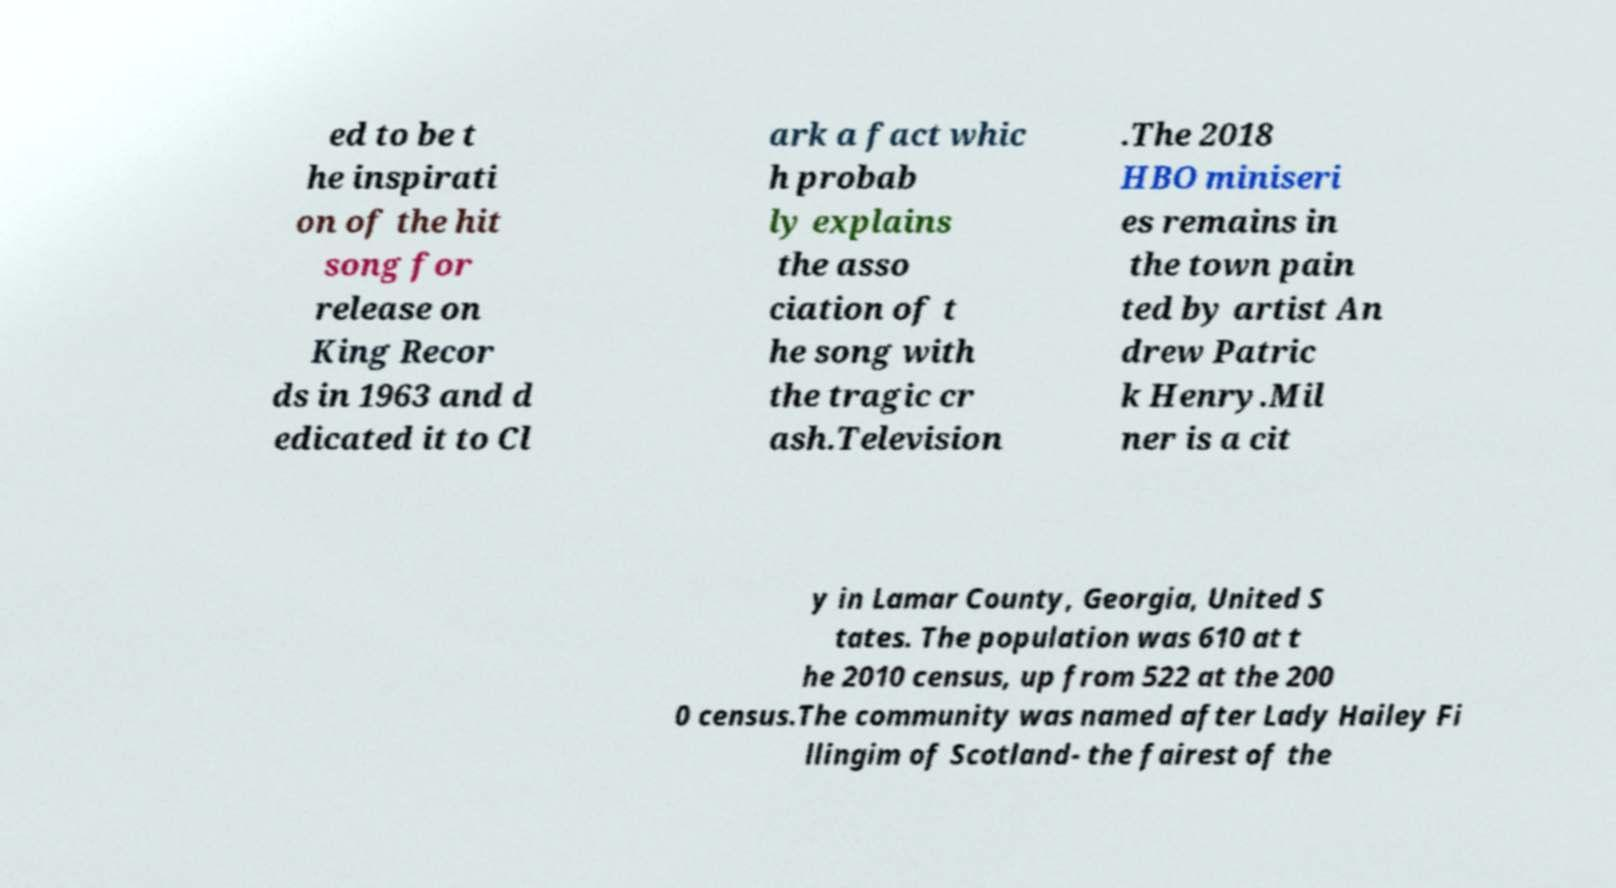Could you assist in decoding the text presented in this image and type it out clearly? ed to be t he inspirati on of the hit song for release on King Recor ds in 1963 and d edicated it to Cl ark a fact whic h probab ly explains the asso ciation of t he song with the tragic cr ash.Television .The 2018 HBO miniseri es remains in the town pain ted by artist An drew Patric k Henry.Mil ner is a cit y in Lamar County, Georgia, United S tates. The population was 610 at t he 2010 census, up from 522 at the 200 0 census.The community was named after Lady Hailey Fi llingim of Scotland- the fairest of the 